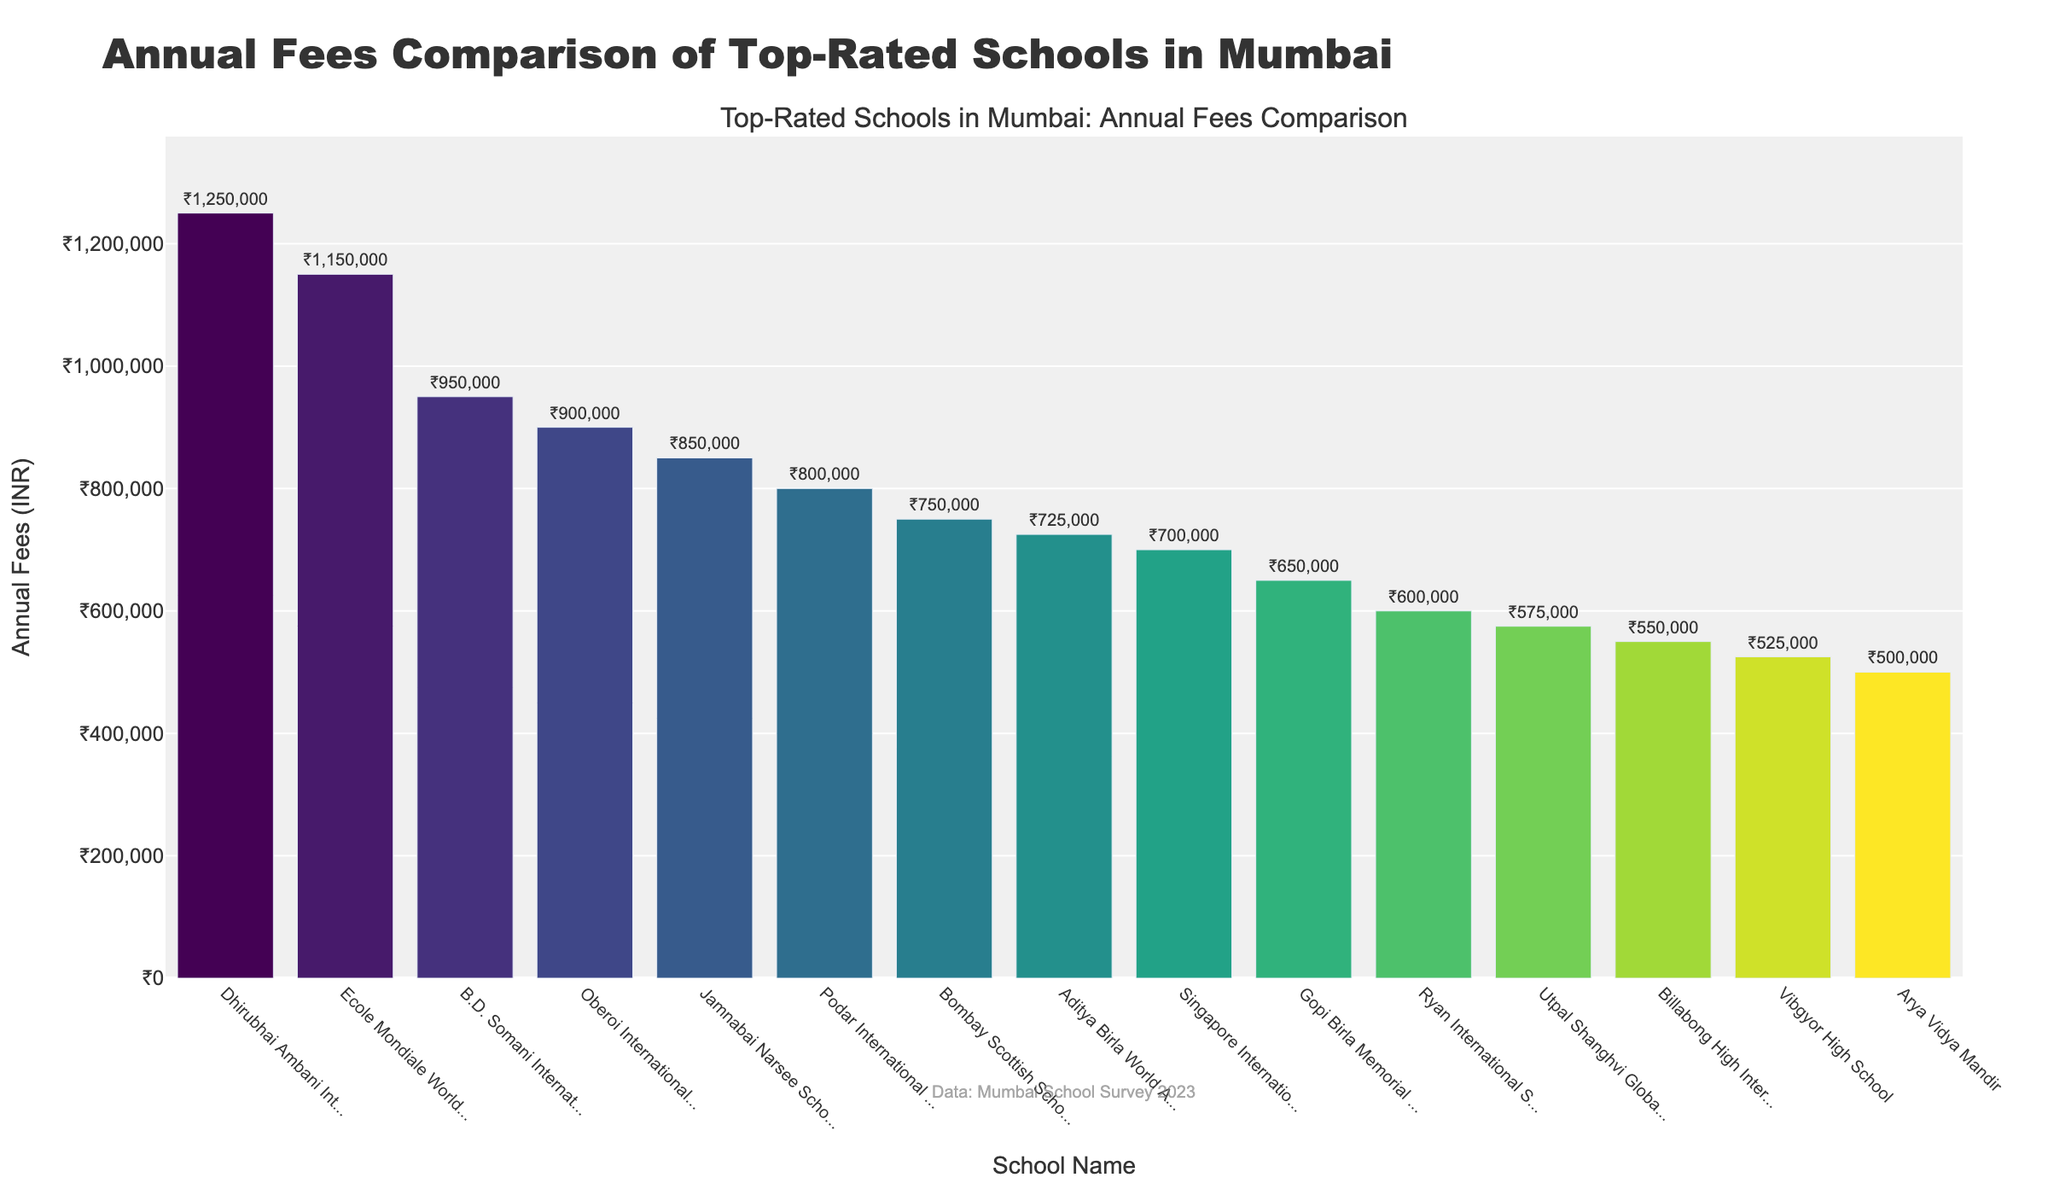What is the school with the highest annual fees? The school with the highest bar represents the school with the highest fees. The bar labeled 'Dhirubhai Ambani International School' is the tallest.
Answer: Dhirubhai Ambani International School Which school has the second highest annual fees? The second tallest bar represents the school with the second highest fees. The bar labeled 'Ecole Mondiale World School' is the second tallest.
Answer: Ecole Mondiale World School How much more are the annual fees of Dhirubhai Ambani International School compared to B.D. Somani International School? Locate the bars for Dhirubhai Ambani International School and B.D. Somani International School. Dhirubhai Ambani International School has fees of ₹1,250,000 and B.D. Somani International School has fees of ₹950,000. The difference is ₹1,250,000 - ₹950,000.
Answer: ₹300,000 What is the range of annual school fees among the top-rated schools? The range is calculated by subtracting the lowest fee from the highest fee. The highest fee is ₹1,250,000 (Dhirubhai Ambani International School) and the lowest fee is ₹500,000 (Arya Vidya Mandir). The range is ₹1,250,000 - ₹500,000.
Answer: ₹750,000 Which school has the lowest annual fees and what is the amount? The shortest bar represents the school with the lowest fees. The bar labeled 'Arya Vidya Mandir' is the shortest.
Answer: Arya Vidya Mandir, ₹500,000 How many schools have annual fees equal to or less than ₹800,000? Count the number of bars that are at or below the ₹800,000 mark. These include Podar International School, Bombay Scottish School, Aditya Birla World Academy, Singapore International School, Gopi Birla Memorial School, Ryan International School, Utpal Shanghvi Global School, Billabong High International School, Vibgyor High School, and Arya Vidya Mandir.
Answer: 10 How does the height of the bar for Oberoi International School compare to Jamnabai Narsee School? The bar for Oberoi International School is slightly taller than that for Jamnabai Narsee School, indicating higher fees.
Answer: Oberoi International School's fees are higher What is the average annual fee of the schools listed? Sum the fees of all schools and divide by the number of schools. The total sum is ₹11,450,000 for 15 schools. The average is calculated as ₹11,450,000 / 15.
Answer: ₹763,333 How does the height of the bar for Bombay Scottish School visually compare to Aditya Birla World Academy? The bar for Bombay Scottish School is slightly higher than the bar for Aditya Birla World Academy, indicating that Bombay Scottish School charges higher fees.
Answer: Bombay Scottish School's fees are higher Which schools have annual fees higher than ₹700,000 but less than ₹1,000,000? Look at the bars between ₹700,000 and ₹1,000,000. The bars for B.D. Somani International School, Oberoi International School, Jamnabai Narsee School, Podar International School, and Bombay Scottish School fall within this range.
Answer: B.D. Somani International School, Oberoi International School, Jamnabai Narsee School, Podar International School, Bombay Scottish School 